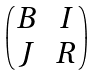<formula> <loc_0><loc_0><loc_500><loc_500>\begin{pmatrix} B & I \\ J & R \end{pmatrix}</formula> 